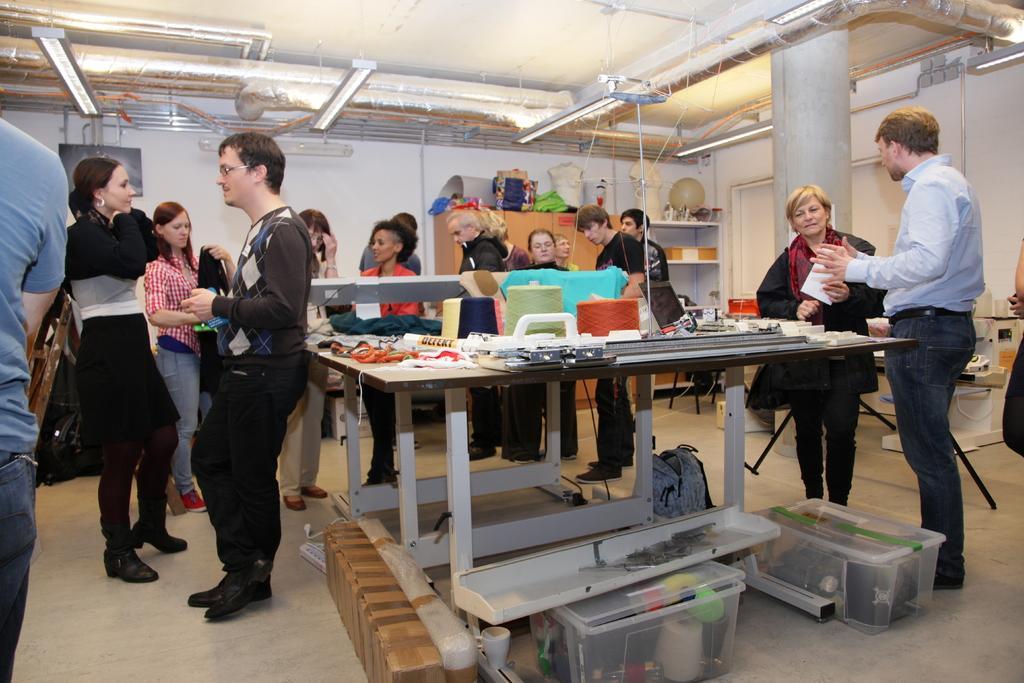Could you give a brief overview of what you see in this image? There are group of people standing in this image. In the center there are two boxes on the floor. There is a table in the center. In the background there are shelves, cupboard. At the right side the man standing is having conversation with the woman in front of her. At the left side the man wearing a black colour dress is leaning on the table. In the background the persons are standing. 